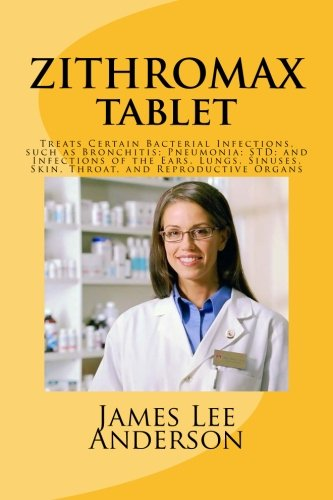What is the title of this book? The title of the book is 'ZITHROMAX Tablet: Treats Certain Bacterial Infections, such as Bronchitis; Pneumonia; STD; and Infections of the Ears, Lungs, Sinuses, Skin, Throat, and Reproductive Organs,' which is a descriptive title outlining the uses of Zithromax. 